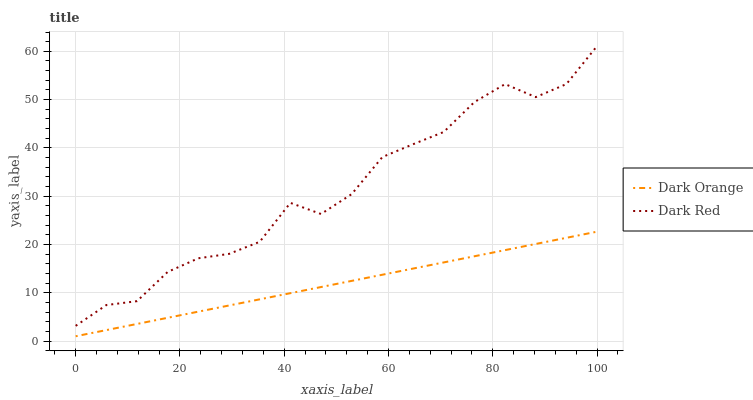Does Dark Orange have the minimum area under the curve?
Answer yes or no. Yes. Does Dark Red have the maximum area under the curve?
Answer yes or no. Yes. Does Dark Red have the minimum area under the curve?
Answer yes or no. No. Is Dark Orange the smoothest?
Answer yes or no. Yes. Is Dark Red the roughest?
Answer yes or no. Yes. Is Dark Red the smoothest?
Answer yes or no. No. Does Dark Orange have the lowest value?
Answer yes or no. Yes. Does Dark Red have the lowest value?
Answer yes or no. No. Does Dark Red have the highest value?
Answer yes or no. Yes. Is Dark Orange less than Dark Red?
Answer yes or no. Yes. Is Dark Red greater than Dark Orange?
Answer yes or no. Yes. Does Dark Orange intersect Dark Red?
Answer yes or no. No. 